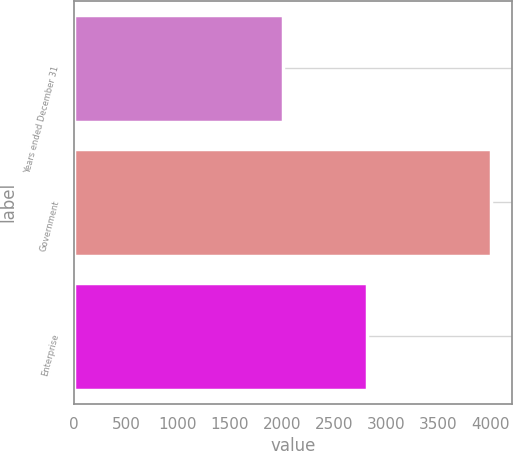Convert chart. <chart><loc_0><loc_0><loc_500><loc_500><bar_chart><fcel>Years ended December 31<fcel>Government<fcel>Enterprise<nl><fcel>2013<fcel>4013<fcel>2820<nl></chart> 